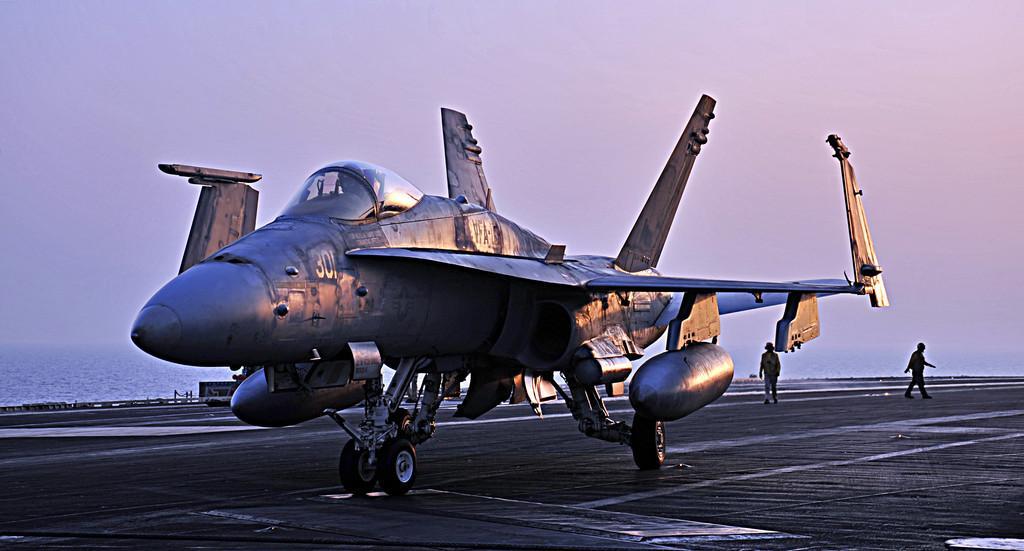How would you summarize this image in a sentence or two? In this image I can see an aircraft, background I can see two persons walking and I can also see the water and the sky is in white and blue color. 